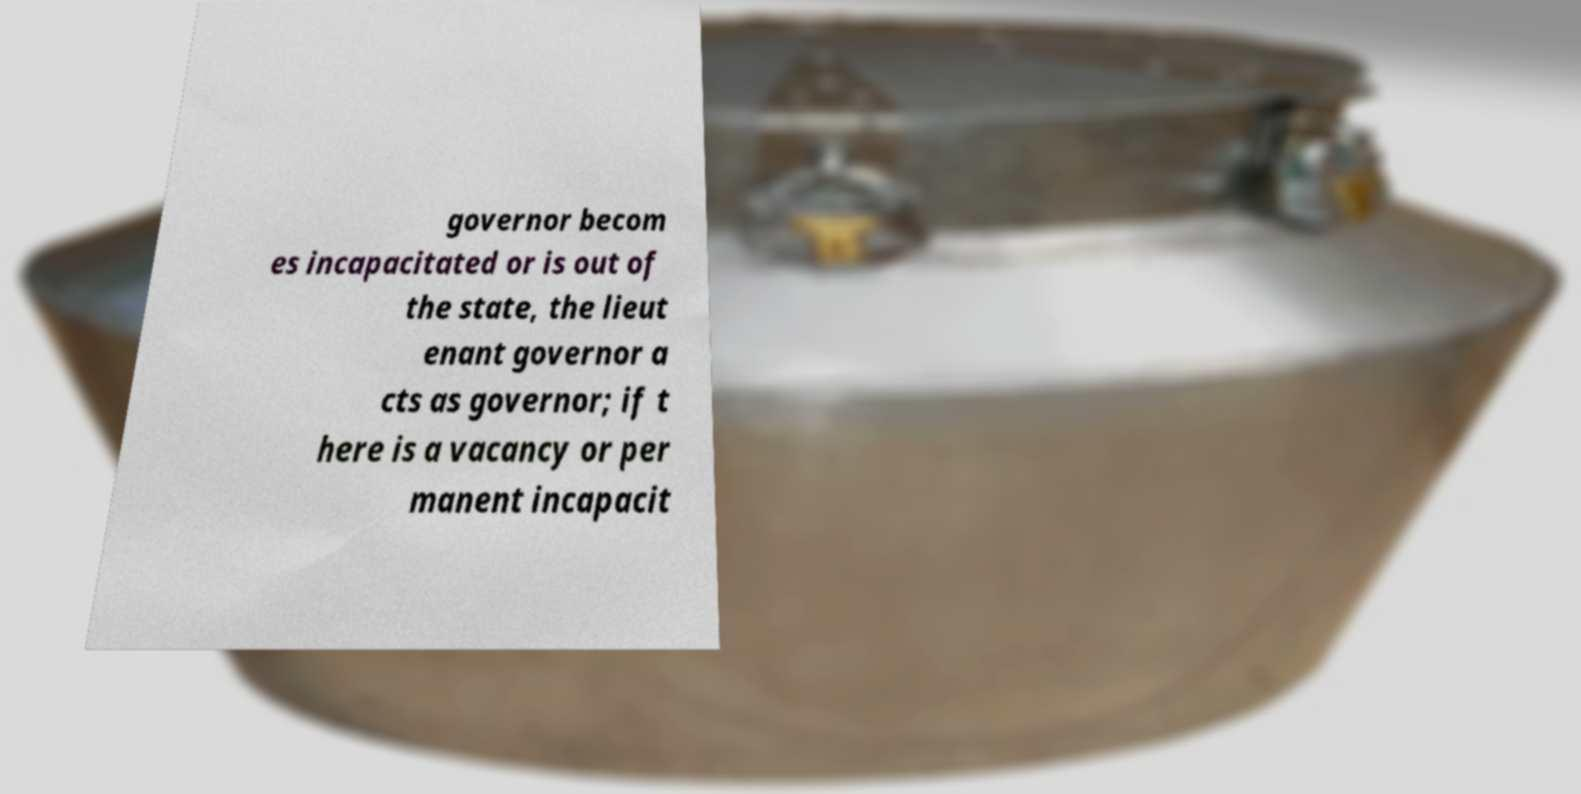Could you assist in decoding the text presented in this image and type it out clearly? governor becom es incapacitated or is out of the state, the lieut enant governor a cts as governor; if t here is a vacancy or per manent incapacit 